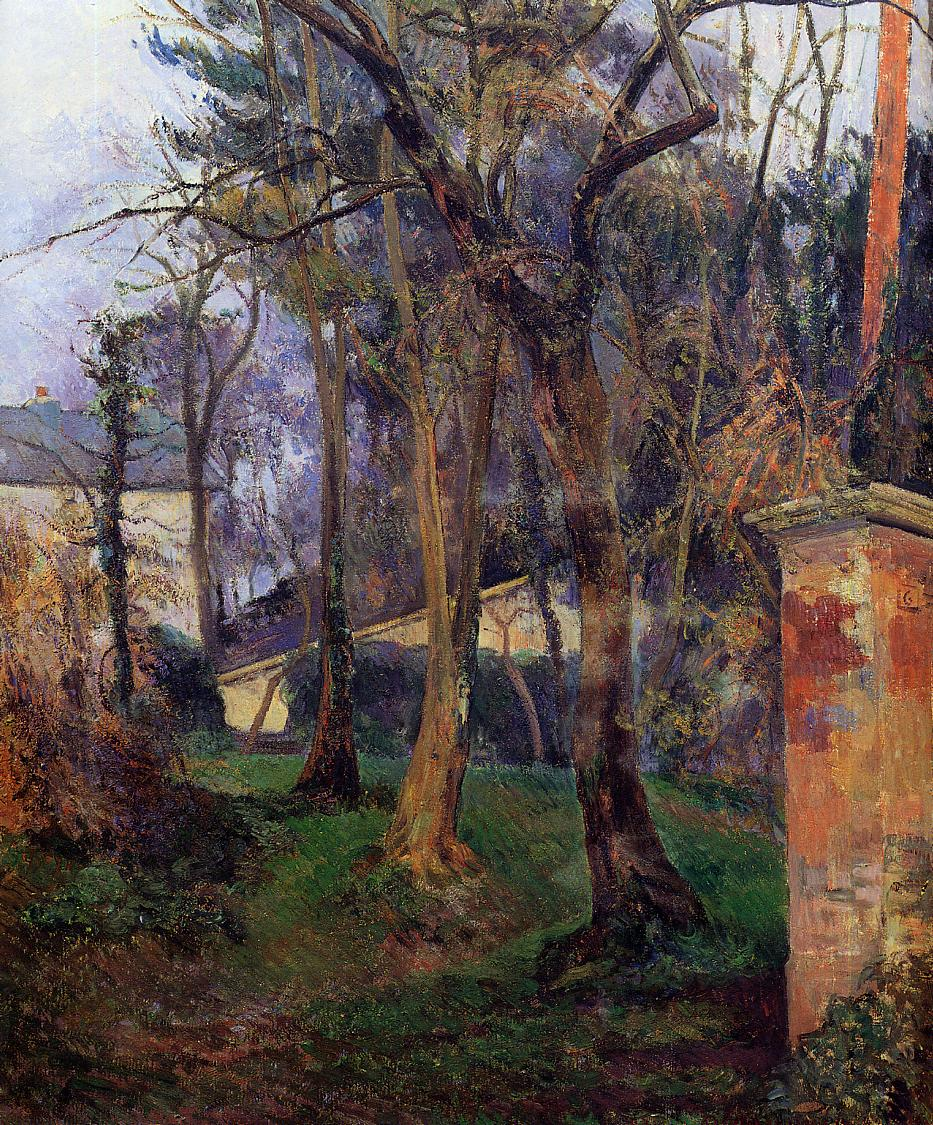Can you tell me a story set in this garden? Once upon a time, in a quaint countryside village, there was a secret garden hidden behind an old stone wall. This garden, with its overgrown paths and lush greenery, was a place of magic and tranquility. It was tended to by an elderly woman named Eliza, who had lived in the adjoining house for as long as anyone could remember. She was known for her kindness and her knack for making plants flourish. Every morning, she would wander through the garden, singing softly to the plants, urging them to grow and bloom. Under her care, the garden became a haven for all kinds of wildlife—birds, butterflies, and even a family of hedgehogs found refuge here.

One day, a young girl named Emily, new to the village and feeling lonely, stumbled upon the garden. She was instantly captivated by its beauty and the peace it exuded. Eliza welcomed her warmly, sharing the secrets of the garden and teaching her about the different plants and their meanings. Over the summer, Emily learned to care for the garden, her friendship with Eliza blossoming as richly as the flowers around them.

As the seasons changed, so did Emily. The shy, lonely girl transformed into a confident, happy individual, all thanks to the magic of the garden and the gentle guidance of Eliza. The garden continued to flourish, remaining a place of joy and solace for the village for generations to come. 